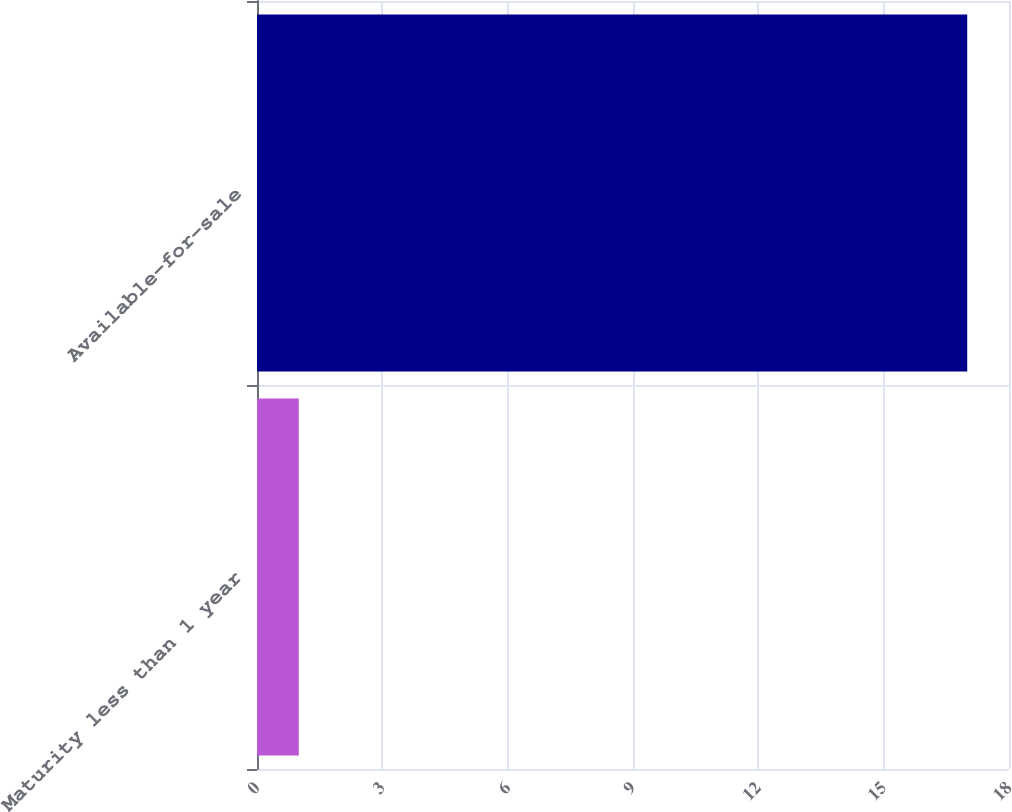Convert chart to OTSL. <chart><loc_0><loc_0><loc_500><loc_500><bar_chart><fcel>Maturity less than 1 year<fcel>Available-for-sale<nl><fcel>1<fcel>17<nl></chart> 